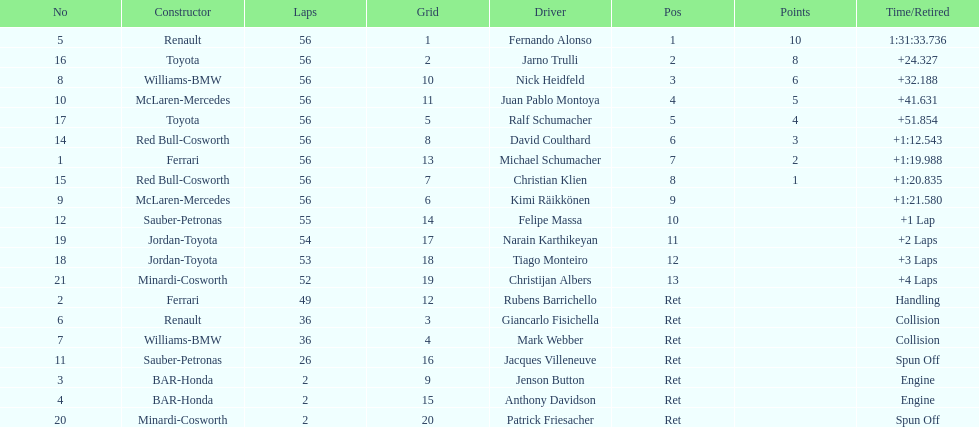Who was the last driver to actually finish the race? Christijan Albers. 